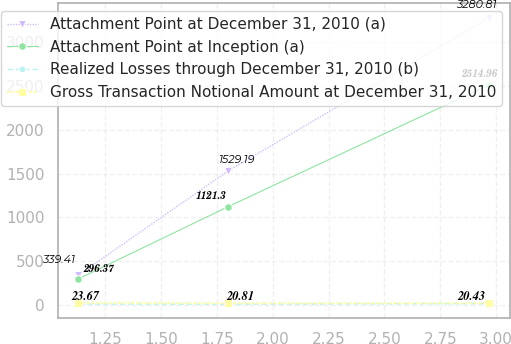<chart> <loc_0><loc_0><loc_500><loc_500><line_chart><ecel><fcel>Attachment Point at December 31, 2010 (a)<fcel>Attachment Point at Inception (a)<fcel>Realized Losses through December 31, 2010 (b)<fcel>Gross Transaction Notional Amount at December 31, 2010<nl><fcel>1.13<fcel>339.41<fcel>296.37<fcel>10.04<fcel>23.67<nl><fcel>1.8<fcel>1529.19<fcel>1121.3<fcel>8.56<fcel>20.81<nl><fcel>2.97<fcel>3280.81<fcel>2514.96<fcel>14.4<fcel>20.43<nl></chart> 